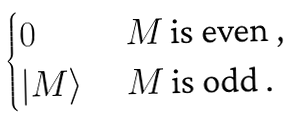Convert formula to latex. <formula><loc_0><loc_0><loc_500><loc_500>\begin{cases} 0 & \text { $ M $ is even ,} \\ | M \rangle & \text { $ M $ is odd .} \end{cases}</formula> 